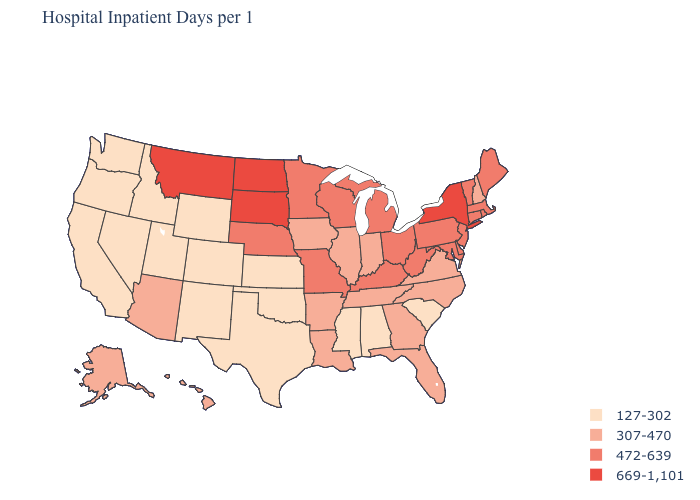What is the lowest value in states that border Minnesota?
Answer briefly. 307-470. Which states have the highest value in the USA?
Quick response, please. Montana, New York, North Dakota, South Dakota. What is the value of Louisiana?
Be succinct. 307-470. Name the states that have a value in the range 472-639?
Quick response, please. Connecticut, Delaware, Kentucky, Maine, Maryland, Massachusetts, Michigan, Minnesota, Missouri, Nebraska, New Jersey, Ohio, Pennsylvania, Rhode Island, Vermont, West Virginia, Wisconsin. What is the lowest value in the USA?
Keep it brief. 127-302. Does Virginia have the same value as Arkansas?
Keep it brief. Yes. Name the states that have a value in the range 472-639?
Keep it brief. Connecticut, Delaware, Kentucky, Maine, Maryland, Massachusetts, Michigan, Minnesota, Missouri, Nebraska, New Jersey, Ohio, Pennsylvania, Rhode Island, Vermont, West Virginia, Wisconsin. Name the states that have a value in the range 669-1,101?
Answer briefly. Montana, New York, North Dakota, South Dakota. Name the states that have a value in the range 307-470?
Keep it brief. Alaska, Arizona, Arkansas, Florida, Georgia, Hawaii, Illinois, Indiana, Iowa, Louisiana, New Hampshire, North Carolina, Tennessee, Virginia. Among the states that border Connecticut , which have the lowest value?
Write a very short answer. Massachusetts, Rhode Island. Among the states that border New Hampshire , which have the highest value?
Give a very brief answer. Maine, Massachusetts, Vermont. What is the highest value in the Northeast ?
Keep it brief. 669-1,101. Which states have the lowest value in the USA?
Be succinct. Alabama, California, Colorado, Idaho, Kansas, Mississippi, Nevada, New Mexico, Oklahoma, Oregon, South Carolina, Texas, Utah, Washington, Wyoming. Name the states that have a value in the range 307-470?
Write a very short answer. Alaska, Arizona, Arkansas, Florida, Georgia, Hawaii, Illinois, Indiana, Iowa, Louisiana, New Hampshire, North Carolina, Tennessee, Virginia. Does the first symbol in the legend represent the smallest category?
Short answer required. Yes. 